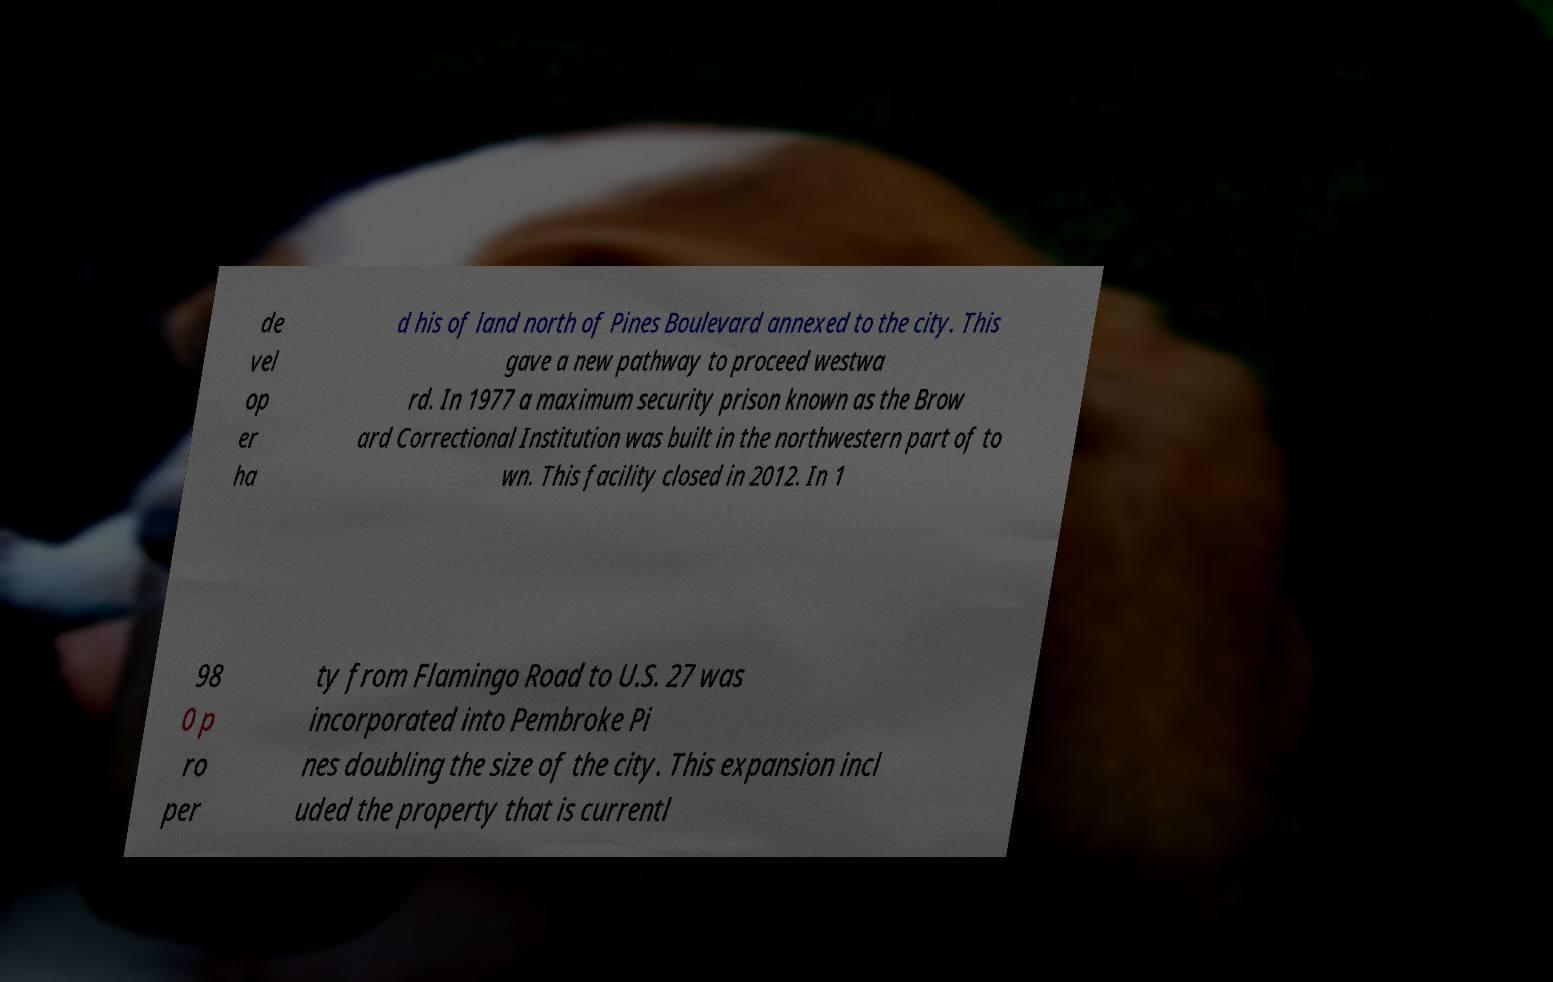Please identify and transcribe the text found in this image. de vel op er ha d his of land north of Pines Boulevard annexed to the city. This gave a new pathway to proceed westwa rd. In 1977 a maximum security prison known as the Brow ard Correctional Institution was built in the northwestern part of to wn. This facility closed in 2012. In 1 98 0 p ro per ty from Flamingo Road to U.S. 27 was incorporated into Pembroke Pi nes doubling the size of the city. This expansion incl uded the property that is currentl 